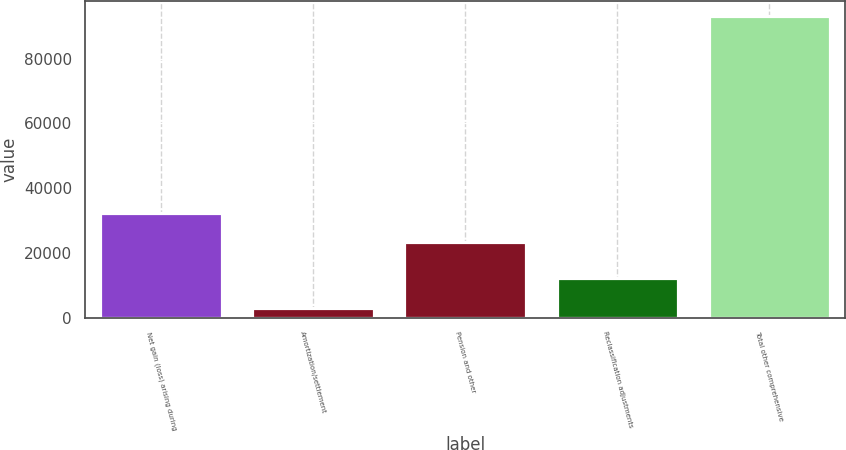<chart> <loc_0><loc_0><loc_500><loc_500><bar_chart><fcel>Net gain (loss) arising during<fcel>Amortization/settlement<fcel>Pension and other<fcel>Reclassification adjustments<fcel>Total other comprehensive<nl><fcel>32310.9<fcel>3113<fcel>23311<fcel>12112.9<fcel>93112<nl></chart> 